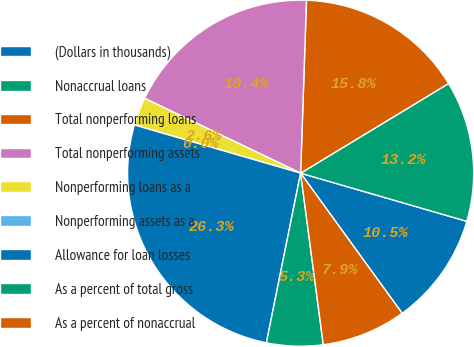Convert chart to OTSL. <chart><loc_0><loc_0><loc_500><loc_500><pie_chart><fcel>(Dollars in thousands)<fcel>Nonaccrual loans<fcel>Total nonperforming loans<fcel>Total nonperforming assets<fcel>Nonperforming loans as a<fcel>Nonperforming assets as a<fcel>Allowance for loan losses<fcel>As a percent of total gross<fcel>As a percent of nonaccrual<nl><fcel>10.53%<fcel>13.16%<fcel>15.79%<fcel>18.42%<fcel>2.63%<fcel>0.0%<fcel>26.32%<fcel>5.26%<fcel>7.89%<nl></chart> 